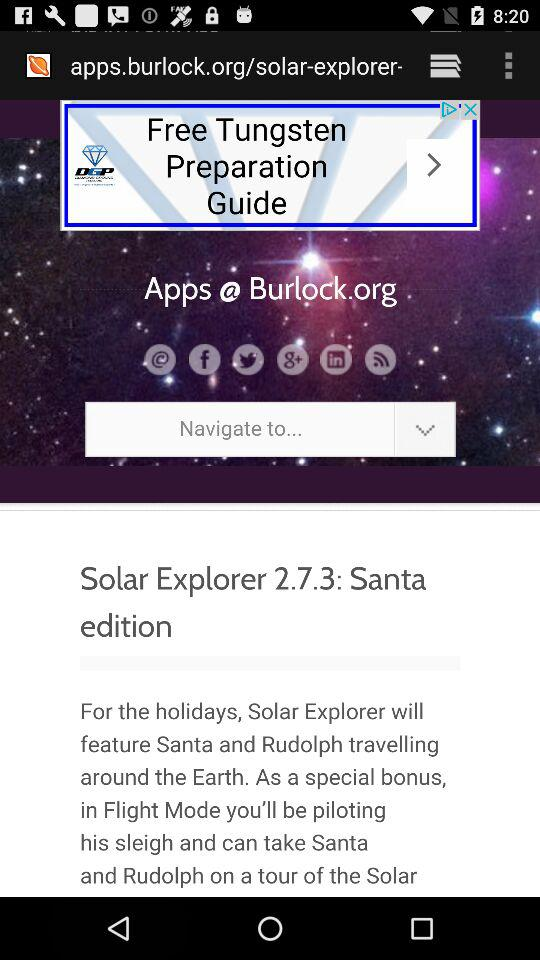What is the version of Solar Explorer? The version is 2.7.3. 